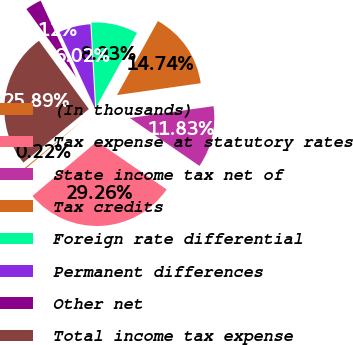Convert chart. <chart><loc_0><loc_0><loc_500><loc_500><pie_chart><fcel>(In thousands)<fcel>Tax expense at statutory rates<fcel>State income tax net of<fcel>Tax credits<fcel>Foreign rate differential<fcel>Permanent differences<fcel>Other net<fcel>Total income tax expense<nl><fcel>0.22%<fcel>29.26%<fcel>11.83%<fcel>14.74%<fcel>8.93%<fcel>6.02%<fcel>3.12%<fcel>25.89%<nl></chart> 